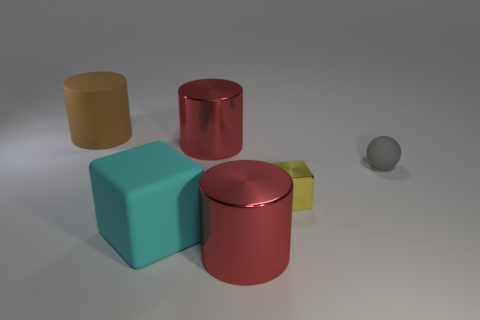What number of purple things are either small metallic cubes or big rubber things?
Keep it short and to the point. 0. Is there a shiny object of the same color as the small cube?
Your response must be concise. No. Is there a red object that has the same material as the big brown object?
Your response must be concise. No. There is a object that is both in front of the tiny gray matte object and behind the rubber cube; what is its shape?
Ensure brevity in your answer.  Cube. What number of big objects are either cylinders or cyan matte objects?
Your answer should be compact. 4. What is the large cyan object made of?
Give a very brief answer. Rubber. How many other objects are the same shape as the gray thing?
Provide a short and direct response. 0. How big is the rubber cube?
Provide a succinct answer. Large. There is a object that is to the right of the large cyan block and behind the tiny gray matte sphere; how big is it?
Give a very brief answer. Large. The large matte object that is behind the matte cube has what shape?
Keep it short and to the point. Cylinder. 